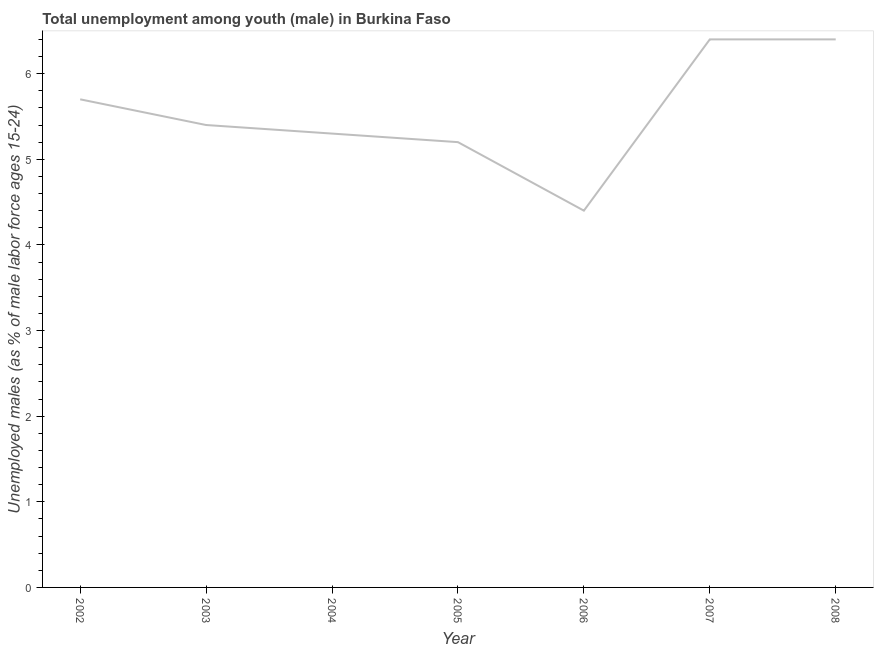What is the unemployed male youth population in 2006?
Offer a terse response. 4.4. Across all years, what is the maximum unemployed male youth population?
Your response must be concise. 6.4. Across all years, what is the minimum unemployed male youth population?
Keep it short and to the point. 4.4. What is the sum of the unemployed male youth population?
Provide a short and direct response. 38.8. What is the difference between the unemployed male youth population in 2006 and 2007?
Keep it short and to the point. -2. What is the average unemployed male youth population per year?
Provide a short and direct response. 5.54. What is the median unemployed male youth population?
Give a very brief answer. 5.4. In how many years, is the unemployed male youth population greater than 5.6 %?
Provide a short and direct response. 3. What is the ratio of the unemployed male youth population in 2005 to that in 2007?
Provide a short and direct response. 0.81. Is the unemployed male youth population in 2002 less than that in 2005?
Keep it short and to the point. No. What is the difference between the highest and the second highest unemployed male youth population?
Provide a short and direct response. 0. What is the difference between the highest and the lowest unemployed male youth population?
Your answer should be very brief. 2. In how many years, is the unemployed male youth population greater than the average unemployed male youth population taken over all years?
Provide a short and direct response. 3. Does the unemployed male youth population monotonically increase over the years?
Your response must be concise. No. How many lines are there?
Offer a terse response. 1. How many years are there in the graph?
Provide a succinct answer. 7. Are the values on the major ticks of Y-axis written in scientific E-notation?
Ensure brevity in your answer.  No. Does the graph contain grids?
Your answer should be very brief. No. What is the title of the graph?
Keep it short and to the point. Total unemployment among youth (male) in Burkina Faso. What is the label or title of the Y-axis?
Keep it short and to the point. Unemployed males (as % of male labor force ages 15-24). What is the Unemployed males (as % of male labor force ages 15-24) of 2002?
Offer a terse response. 5.7. What is the Unemployed males (as % of male labor force ages 15-24) in 2003?
Provide a short and direct response. 5.4. What is the Unemployed males (as % of male labor force ages 15-24) of 2004?
Offer a terse response. 5.3. What is the Unemployed males (as % of male labor force ages 15-24) of 2005?
Provide a short and direct response. 5.2. What is the Unemployed males (as % of male labor force ages 15-24) of 2006?
Your response must be concise. 4.4. What is the Unemployed males (as % of male labor force ages 15-24) of 2007?
Ensure brevity in your answer.  6.4. What is the Unemployed males (as % of male labor force ages 15-24) in 2008?
Your answer should be compact. 6.4. What is the difference between the Unemployed males (as % of male labor force ages 15-24) in 2002 and 2003?
Offer a terse response. 0.3. What is the difference between the Unemployed males (as % of male labor force ages 15-24) in 2002 and 2004?
Your answer should be compact. 0.4. What is the difference between the Unemployed males (as % of male labor force ages 15-24) in 2002 and 2005?
Offer a terse response. 0.5. What is the difference between the Unemployed males (as % of male labor force ages 15-24) in 2002 and 2006?
Your answer should be very brief. 1.3. What is the difference between the Unemployed males (as % of male labor force ages 15-24) in 2002 and 2008?
Your answer should be compact. -0.7. What is the difference between the Unemployed males (as % of male labor force ages 15-24) in 2003 and 2005?
Offer a very short reply. 0.2. What is the difference between the Unemployed males (as % of male labor force ages 15-24) in 2003 and 2006?
Provide a short and direct response. 1. What is the difference between the Unemployed males (as % of male labor force ages 15-24) in 2003 and 2007?
Offer a very short reply. -1. What is the difference between the Unemployed males (as % of male labor force ages 15-24) in 2003 and 2008?
Your answer should be compact. -1. What is the difference between the Unemployed males (as % of male labor force ages 15-24) in 2005 and 2007?
Keep it short and to the point. -1.2. What is the difference between the Unemployed males (as % of male labor force ages 15-24) in 2005 and 2008?
Your answer should be very brief. -1.2. What is the difference between the Unemployed males (as % of male labor force ages 15-24) in 2006 and 2007?
Your response must be concise. -2. What is the ratio of the Unemployed males (as % of male labor force ages 15-24) in 2002 to that in 2003?
Offer a terse response. 1.06. What is the ratio of the Unemployed males (as % of male labor force ages 15-24) in 2002 to that in 2004?
Make the answer very short. 1.07. What is the ratio of the Unemployed males (as % of male labor force ages 15-24) in 2002 to that in 2005?
Offer a terse response. 1.1. What is the ratio of the Unemployed males (as % of male labor force ages 15-24) in 2002 to that in 2006?
Provide a succinct answer. 1.29. What is the ratio of the Unemployed males (as % of male labor force ages 15-24) in 2002 to that in 2007?
Provide a short and direct response. 0.89. What is the ratio of the Unemployed males (as % of male labor force ages 15-24) in 2002 to that in 2008?
Provide a succinct answer. 0.89. What is the ratio of the Unemployed males (as % of male labor force ages 15-24) in 2003 to that in 2005?
Offer a terse response. 1.04. What is the ratio of the Unemployed males (as % of male labor force ages 15-24) in 2003 to that in 2006?
Offer a very short reply. 1.23. What is the ratio of the Unemployed males (as % of male labor force ages 15-24) in 2003 to that in 2007?
Provide a succinct answer. 0.84. What is the ratio of the Unemployed males (as % of male labor force ages 15-24) in 2003 to that in 2008?
Offer a terse response. 0.84. What is the ratio of the Unemployed males (as % of male labor force ages 15-24) in 2004 to that in 2005?
Provide a succinct answer. 1.02. What is the ratio of the Unemployed males (as % of male labor force ages 15-24) in 2004 to that in 2006?
Provide a short and direct response. 1.21. What is the ratio of the Unemployed males (as % of male labor force ages 15-24) in 2004 to that in 2007?
Offer a very short reply. 0.83. What is the ratio of the Unemployed males (as % of male labor force ages 15-24) in 2004 to that in 2008?
Provide a succinct answer. 0.83. What is the ratio of the Unemployed males (as % of male labor force ages 15-24) in 2005 to that in 2006?
Provide a succinct answer. 1.18. What is the ratio of the Unemployed males (as % of male labor force ages 15-24) in 2005 to that in 2007?
Make the answer very short. 0.81. What is the ratio of the Unemployed males (as % of male labor force ages 15-24) in 2005 to that in 2008?
Make the answer very short. 0.81. What is the ratio of the Unemployed males (as % of male labor force ages 15-24) in 2006 to that in 2007?
Make the answer very short. 0.69. What is the ratio of the Unemployed males (as % of male labor force ages 15-24) in 2006 to that in 2008?
Your response must be concise. 0.69. 